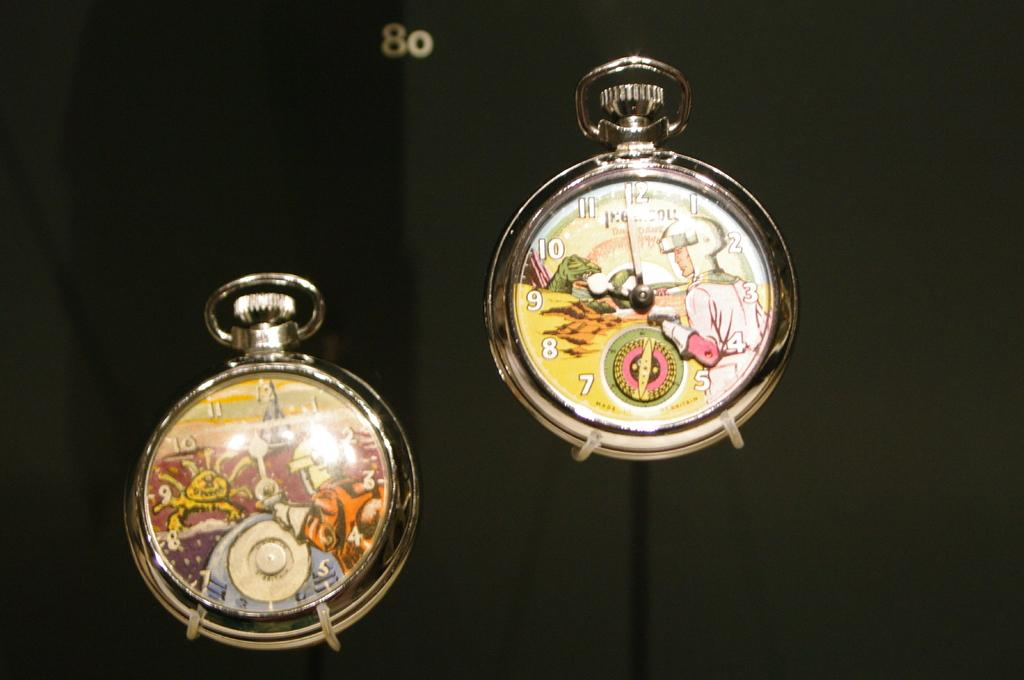<image>
Share a concise interpretation of the image provided. the letters on a watch with one that says 8 